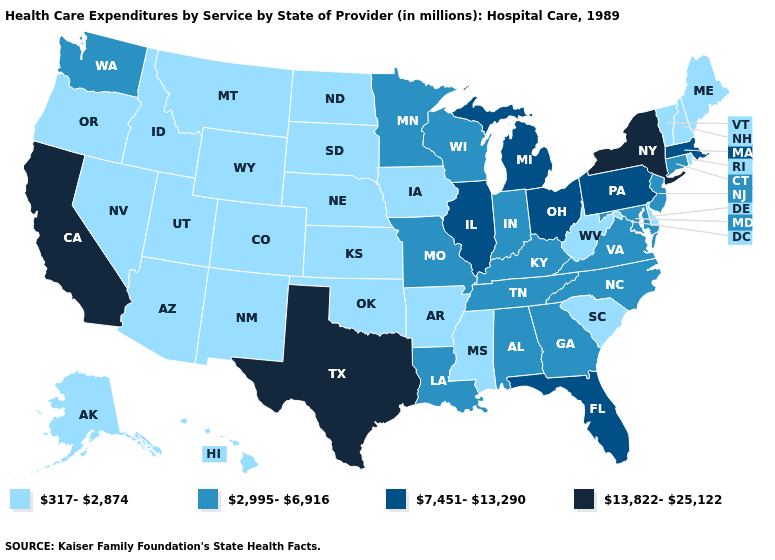What is the value of Connecticut?
Be succinct. 2,995-6,916. What is the lowest value in states that border Minnesota?
Give a very brief answer. 317-2,874. Name the states that have a value in the range 7,451-13,290?
Answer briefly. Florida, Illinois, Massachusetts, Michigan, Ohio, Pennsylvania. Name the states that have a value in the range 13,822-25,122?
Keep it brief. California, New York, Texas. Among the states that border Oklahoma , does New Mexico have the highest value?
Answer briefly. No. Which states hav the highest value in the MidWest?
Short answer required. Illinois, Michigan, Ohio. Among the states that border Ohio , which have the highest value?
Answer briefly. Michigan, Pennsylvania. Does California have the highest value in the West?
Short answer required. Yes. What is the value of Nevada?
Write a very short answer. 317-2,874. Among the states that border Maryland , does West Virginia have the lowest value?
Answer briefly. Yes. What is the highest value in the USA?
Short answer required. 13,822-25,122. What is the value of Vermont?
Quick response, please. 317-2,874. What is the value of Oregon?
Be succinct. 317-2,874. Name the states that have a value in the range 7,451-13,290?
Be succinct. Florida, Illinois, Massachusetts, Michigan, Ohio, Pennsylvania. Name the states that have a value in the range 2,995-6,916?
Answer briefly. Alabama, Connecticut, Georgia, Indiana, Kentucky, Louisiana, Maryland, Minnesota, Missouri, New Jersey, North Carolina, Tennessee, Virginia, Washington, Wisconsin. 